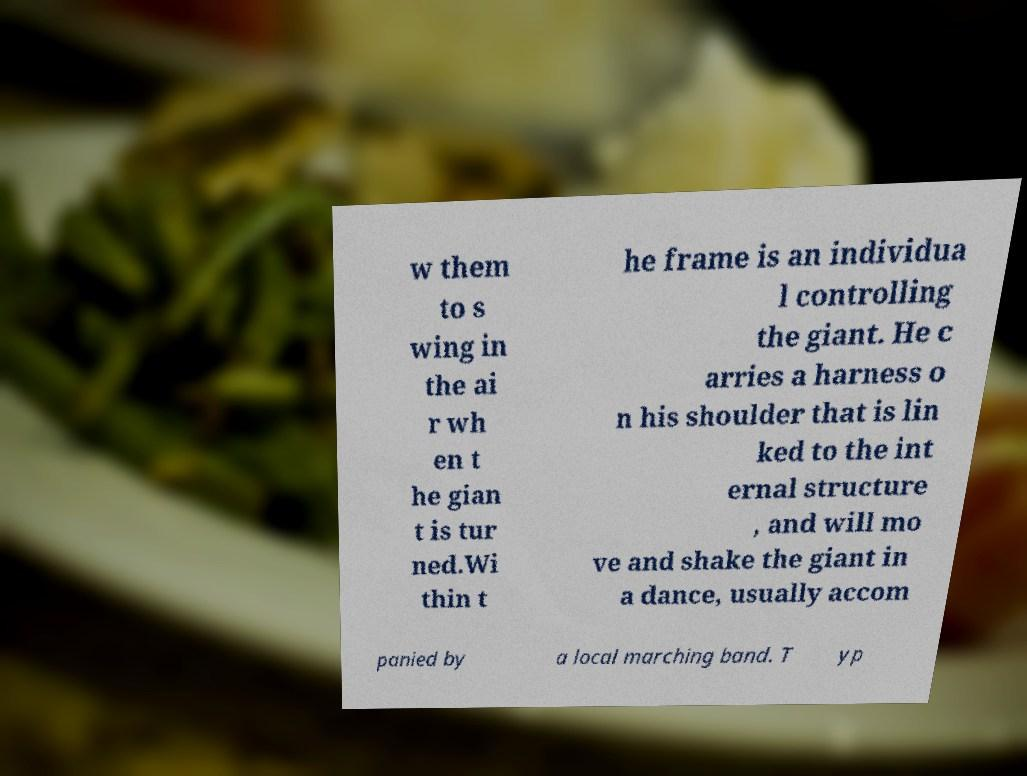I need the written content from this picture converted into text. Can you do that? w them to s wing in the ai r wh en t he gian t is tur ned.Wi thin t he frame is an individua l controlling the giant. He c arries a harness o n his shoulder that is lin ked to the int ernal structure , and will mo ve and shake the giant in a dance, usually accom panied by a local marching band. T yp 